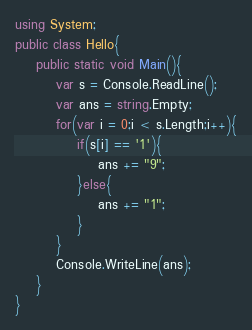<code> <loc_0><loc_0><loc_500><loc_500><_C#_>using System;
public class Hello{
    public static void Main(){
        var s = Console.ReadLine();
        var ans = string.Empty;
        for(var i = 0;i < s.Length;i++){
            if(s[i] == '1'){
                ans += "9";
            }else{
                ans += "1";
            }
        }
        Console.WriteLine(ans);
    }
}
</code> 